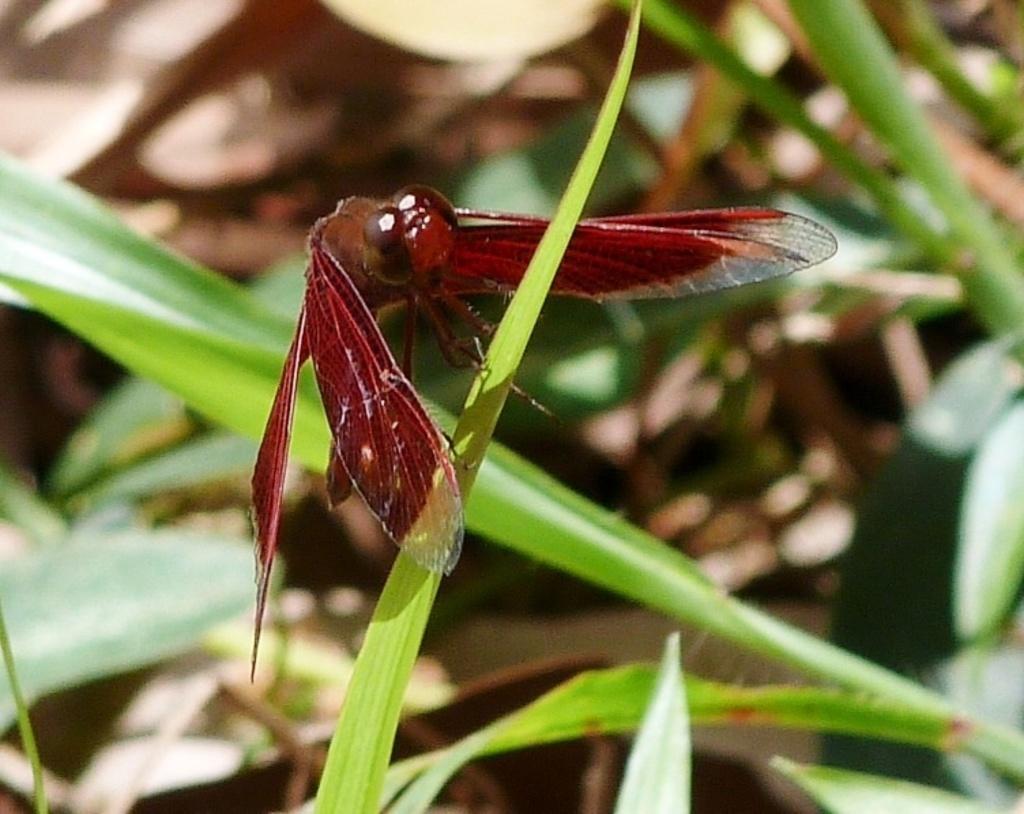Please provide a concise description of this image. In this image we can see an insect on the grass and in the background the image is blurred. 